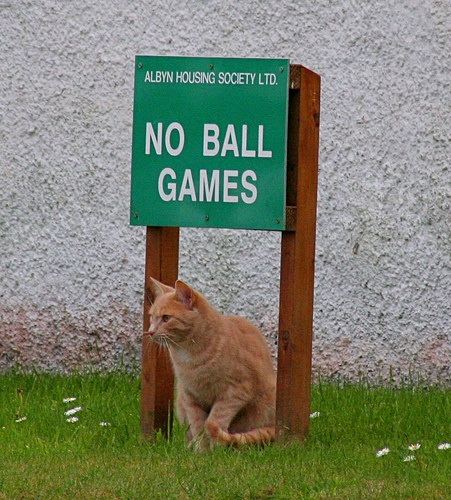Describe the objects in this image and their specific colors. I can see a cat in darkgray, gray, maroon, and brown tones in this image. 